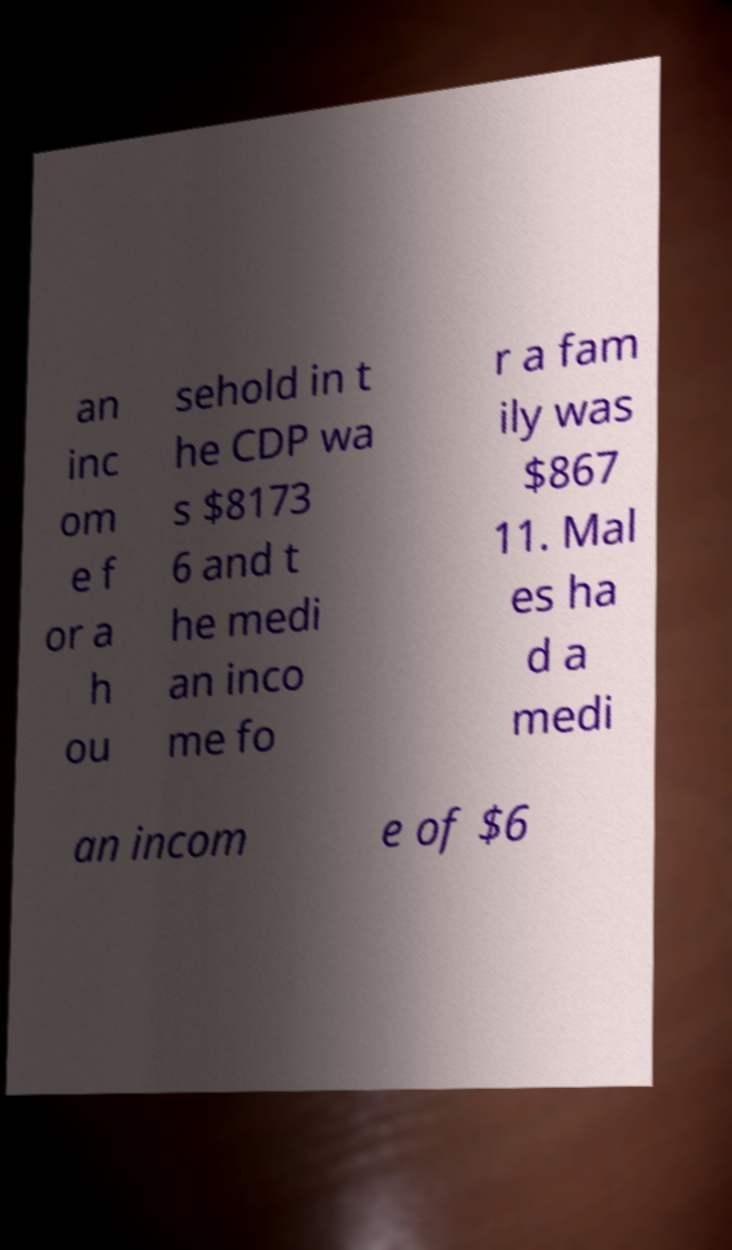Could you extract and type out the text from this image? an inc om e f or a h ou sehold in t he CDP wa s $8173 6 and t he medi an inco me fo r a fam ily was $867 11. Mal es ha d a medi an incom e of $6 